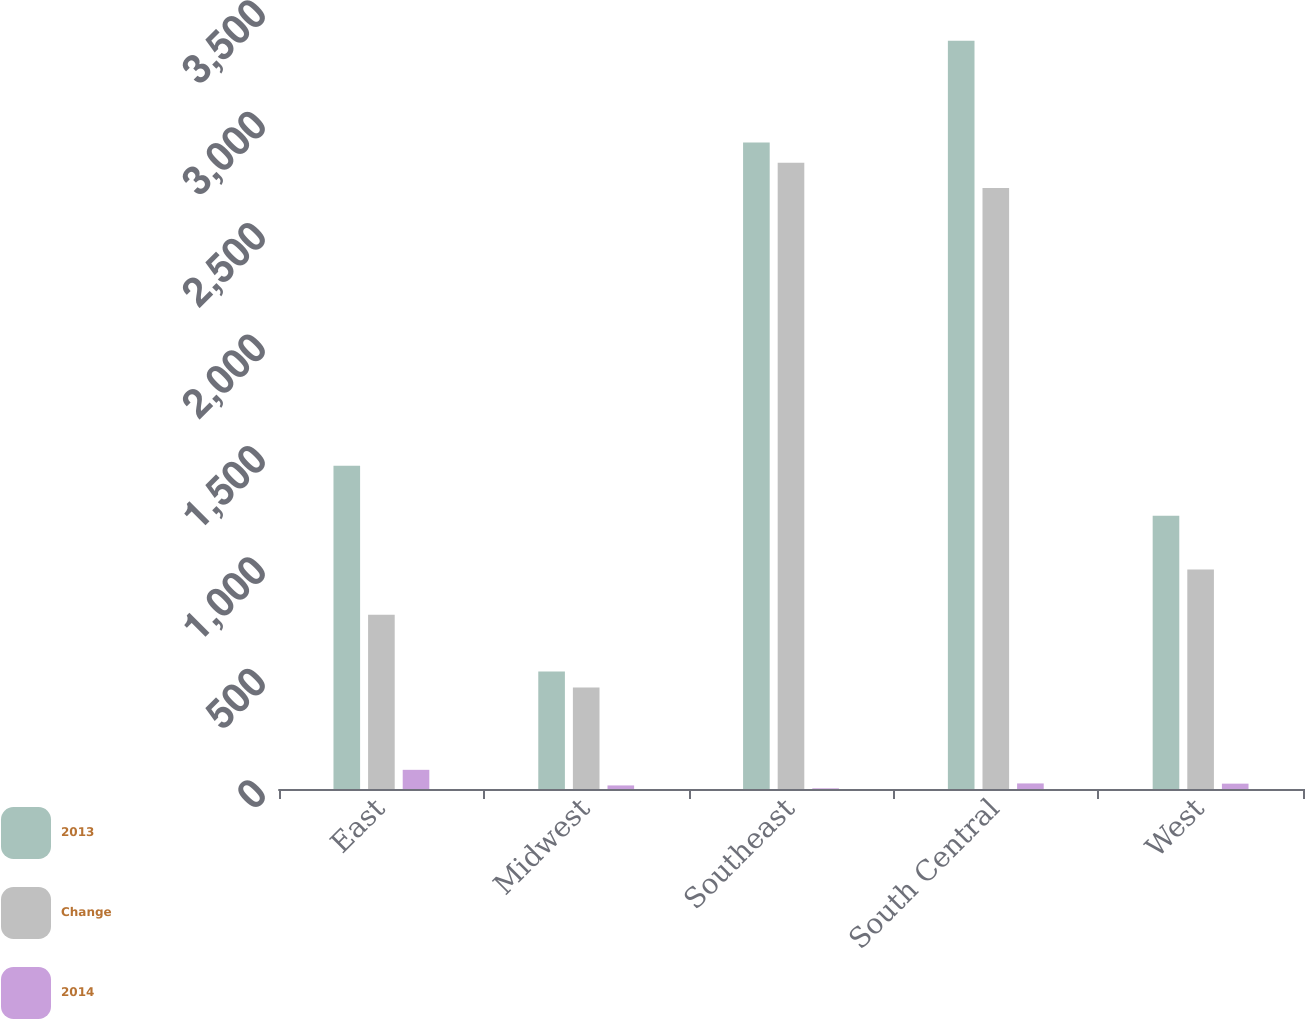Convert chart. <chart><loc_0><loc_0><loc_500><loc_500><stacked_bar_chart><ecel><fcel>East<fcel>Midwest<fcel>Southeast<fcel>South Central<fcel>West<nl><fcel>2013<fcel>1451<fcel>527<fcel>2901<fcel>3358<fcel>1226<nl><fcel>Change<fcel>782<fcel>456<fcel>2810<fcel>2697<fcel>985<nl><fcel>2014<fcel>86<fcel>16<fcel>3<fcel>25<fcel>24<nl></chart> 